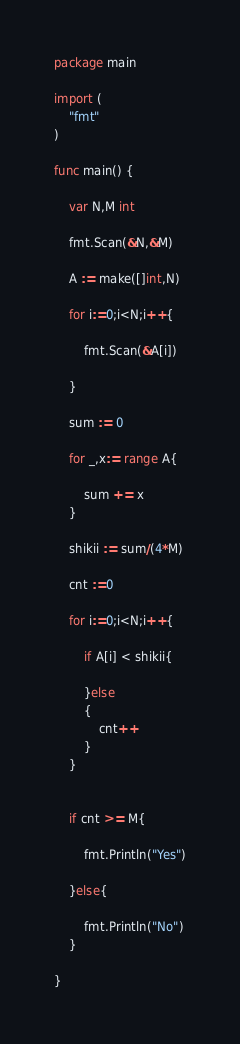<code> <loc_0><loc_0><loc_500><loc_500><_Go_>package main

import (
	"fmt"
)

func main() {

	var N,M int

	fmt.Scan(&N,&M)

	A := make([]int,N)

	for i:=0;i<N;i++{

		fmt.Scan(&A[i])

	}

	sum := 0

	for _,x:= range A{

		sum += x
	}

	shikii := sum/(4*M)

	cnt :=0

	for i:=0;i<N;i++{

		if A[i] < shikii{
			
		}else
		{
			cnt++
		}
	}


	if cnt >= M{

		fmt.Println("Yes")

	}else{

		fmt.Println("No")
	}

}</code> 